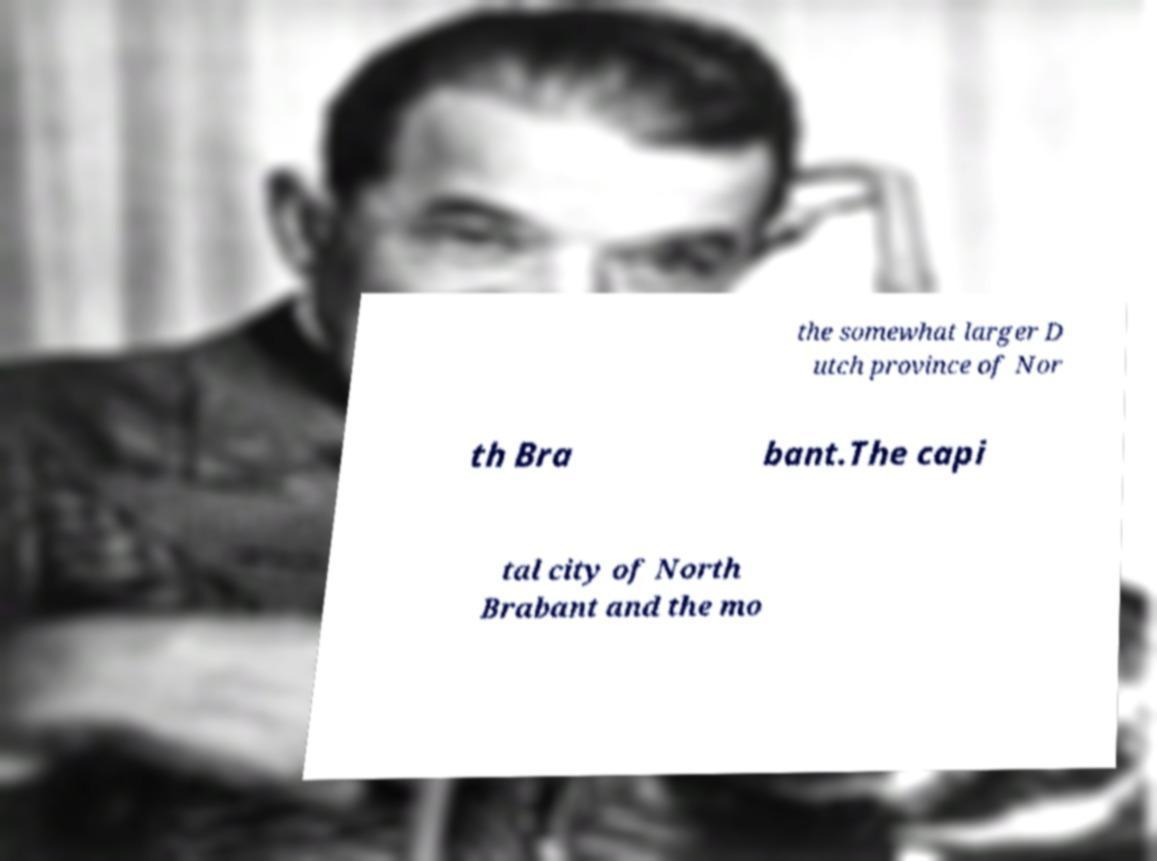Could you extract and type out the text from this image? the somewhat larger D utch province of Nor th Bra bant.The capi tal city of North Brabant and the mo 